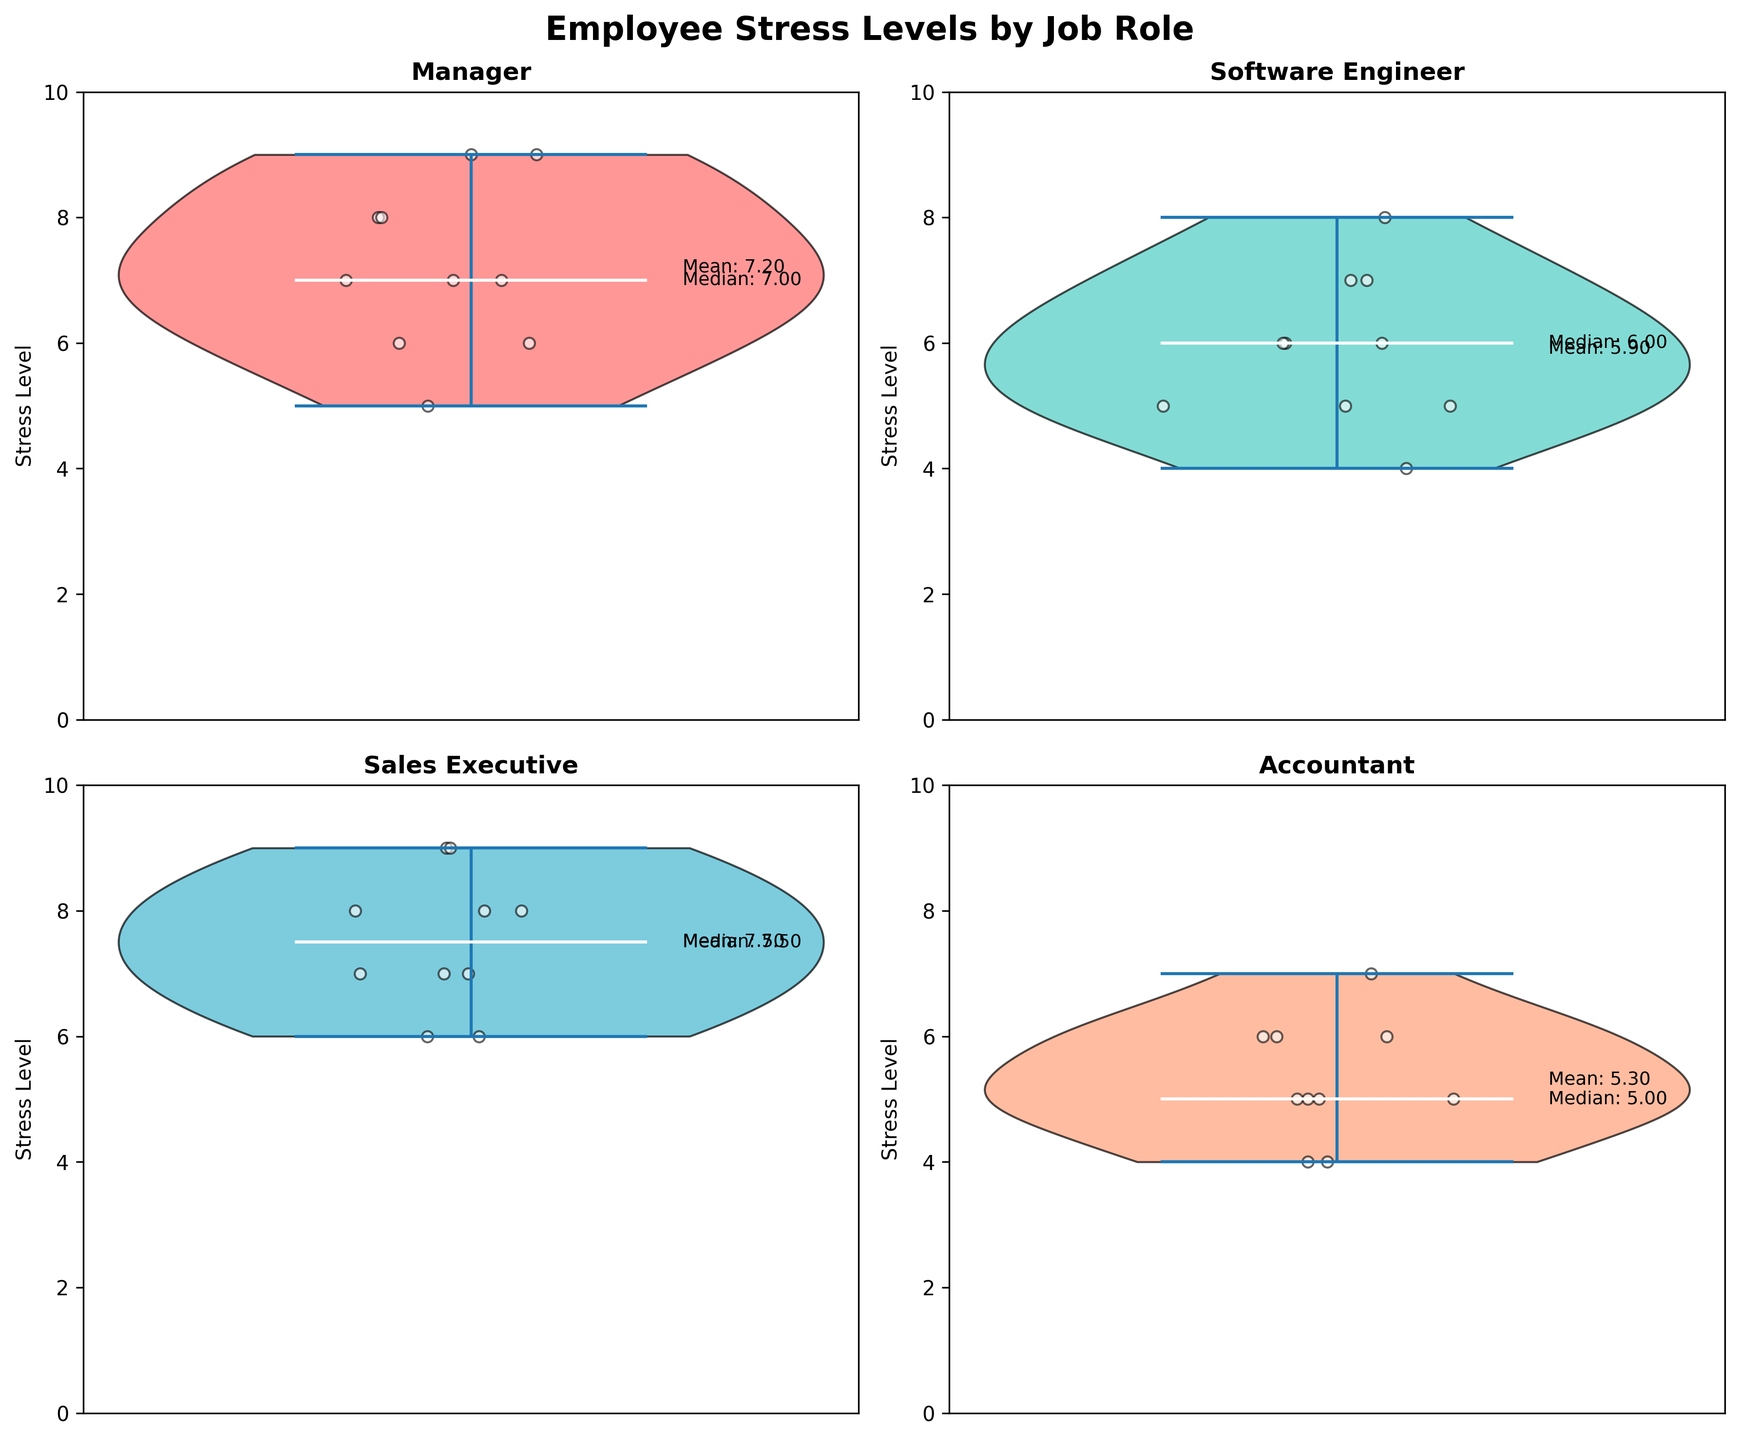What is the title of the figure? The title is located at the top of the figure and usually describes the main topic or purpose. In this case, it is mentioned in the code.
Answer: Employee Stress Levels by Job Role Which job role has the highest median stress level? The median is shown in white on the violin plots. By looking at the white lines, the job role with the highest median can be identified.
Answer: Sales Executive What is the range of stress levels for Software Engineers? The range can be determined by looking at the highest and lowest points within the violin plot for Software Engineers.
Answer: 4 to 8 How many subplots are in the figure? The figure contains four job roles, each represented by a separate subplot.
Answer: 4 Which job role has the lowest mean stress level? The mean is provided as a numerical annotation on each subplot. By comparing these numbers, the job role with the lowest mean can be identified.
Answer: Accountant What color is used for the Manager's violin plot? The color can be identified by looking at the Manager's subplot in the figure.
Answer: Red Compare the median stress levels of Managers and Accountants. Which one is higher? Compare the white median lines within the Manager and Accountant violin plots to determine which is higher.
Answer: Manager What is the mean stress level for Sales Executives? The mean value is annotated on the Sales Executive's subplot.
Answer: Around 7.5 Are the stress levels for Managers spread out more than for Accountants? By comparing the width and shape of the violin plots for Managers and Accountants, the spread or distribution can be assessed.
Answer: Yes Is the stress level distribution for Software Engineers symmetric? The symmetry of the distribution can be determined by observing the shape of the violin plot for Software Engineers.
Answer: No 